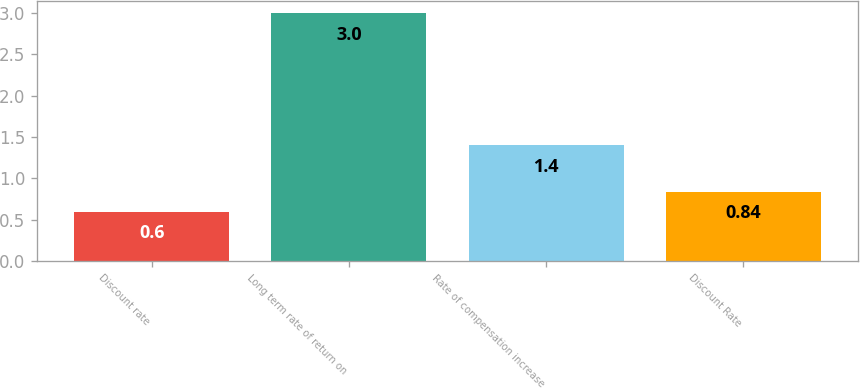Convert chart to OTSL. <chart><loc_0><loc_0><loc_500><loc_500><bar_chart><fcel>Discount rate<fcel>Long term rate of return on<fcel>Rate of compensation increase<fcel>Discount Rate<nl><fcel>0.6<fcel>3<fcel>1.4<fcel>0.84<nl></chart> 